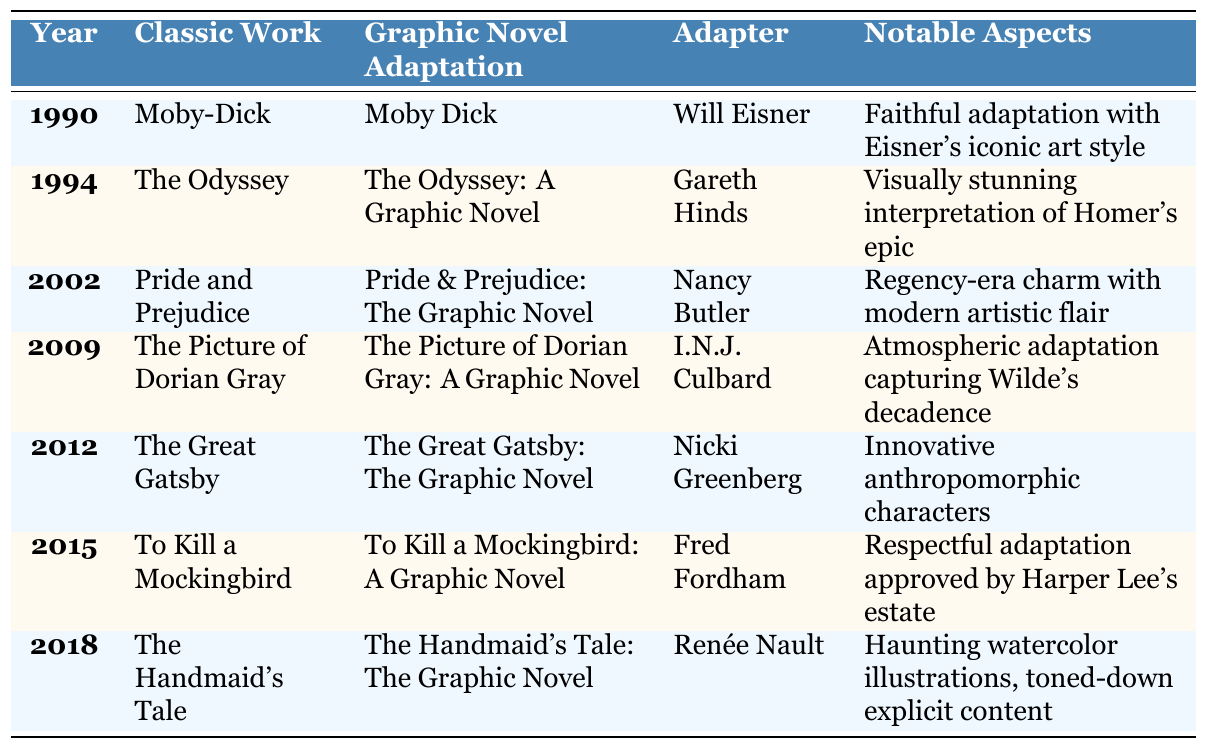What year was the graphic novel adaptation of "The Great Gatsby" released? The table lists the year for each graphic novel adaptation. Looking at the row for "The Great Gatsby," it shows that the adaptation was released in 2012.
Answer: 2012 Who adapted "The Picture of Dorian Gray"? The table provides the name of the adapter for each classic work. In the row for "The Picture of Dorian Gray," it states that I.N.J. Culbard is the adapter.
Answer: I.N.J. Culbard How many graphic novel adaptations were released in the 1990s? By examining the rows, we see that there are two graphic novel adaptations listed from the 1990s: "Moby-Dick" in 1990 and "The Odyssey" in 1994. Counting these gives us a total of 2.
Answer: 2 Is "To Kill a Mockingbird" adaptation approved by Harper Lee's estate? The table indicates notable aspects for each adaptation. For "To Kill a Mockingbird," it states that the adaptation is respectful and approved by Harper Lee's estate, which confirms that the fact is true.
Answer: Yes Which graphic novel adaptation features haunting watercolor illustrations? The provided details in the table reveal that "The Handmaid's Tale" includes haunting watercolor illustrations in its notable aspects.
Answer: The Handmaid's Tale What is the notable aspect of "Pride and Prejudice" graphic novel adaptation? The table specifies that “Pride and Prejudice” is noted for its Regency-era charm combined with modern artistic flair.
Answer: Regency-era charm with modern artistic flair How many adaptations were done before 2010? The adaptations before 2010 listed in the table are from the years 1990, 1994, 2002, and 2009. This totals 4 adaptations.
Answer: 4 Was there an adaptation that toned down explicit content? The notable aspects column of "The Handmaid's Tale" adaptation indicates that the illustrations are haunting and that it toned down explicit content, confirming this fact.
Answer: Yes What is the earliest adaptation among the listed graphic novels? By checking the years in the table, "Moby-Dick" from 1990 is identified as the earliest adaptation among those listed.
Answer: 1990 Which adapter worked on the most recent adaptation in the table? The latest year presented for an adaptation is 2018 for "The Handmaid's Tale," and the adapter listed for this work is Renée Nault.
Answer: Renée Nault 